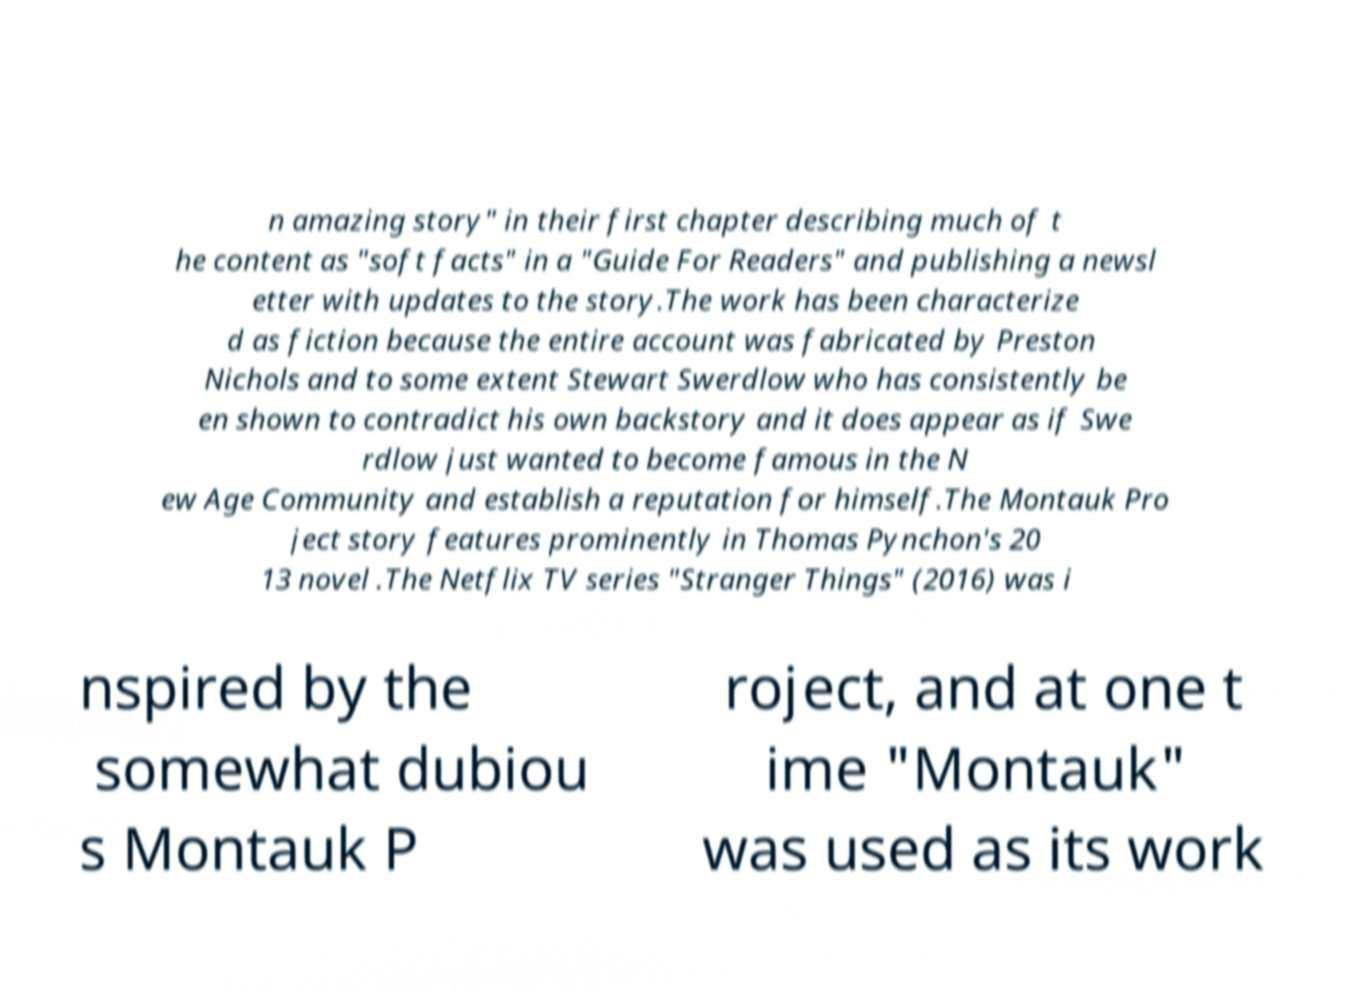What messages or text are displayed in this image? I need them in a readable, typed format. n amazing story" in their first chapter describing much of t he content as "soft facts" in a "Guide For Readers" and publishing a newsl etter with updates to the story.The work has been characterize d as fiction because the entire account was fabricated by Preston Nichols and to some extent Stewart Swerdlow who has consistently be en shown to contradict his own backstory and it does appear as if Swe rdlow just wanted to become famous in the N ew Age Community and establish a reputation for himself.The Montauk Pro ject story features prominently in Thomas Pynchon's 20 13 novel .The Netflix TV series "Stranger Things" (2016) was i nspired by the somewhat dubiou s Montauk P roject, and at one t ime "Montauk" was used as its work 